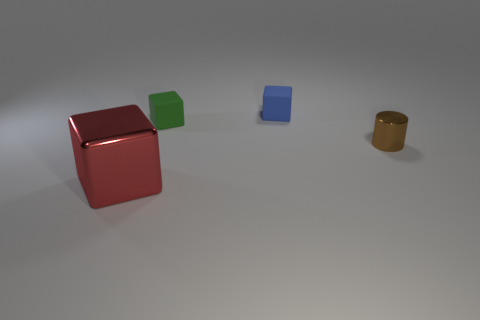Subtract all small cubes. How many cubes are left? 1 Add 3 small green objects. How many objects exist? 7 Subtract all cubes. How many objects are left? 1 Subtract all yellow blocks. Subtract all cyan cylinders. How many blocks are left? 3 Add 1 red shiny cubes. How many red shiny cubes exist? 2 Subtract 0 blue balls. How many objects are left? 4 Subtract all metal cubes. Subtract all red things. How many objects are left? 2 Add 3 metal blocks. How many metal blocks are left? 4 